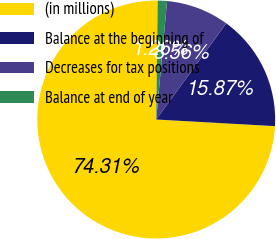<chart> <loc_0><loc_0><loc_500><loc_500><pie_chart><fcel>(in millions)<fcel>Balance at the beginning of<fcel>Decreases for tax positions<fcel>Balance at end of year<nl><fcel>74.31%<fcel>15.87%<fcel>8.56%<fcel>1.26%<nl></chart> 